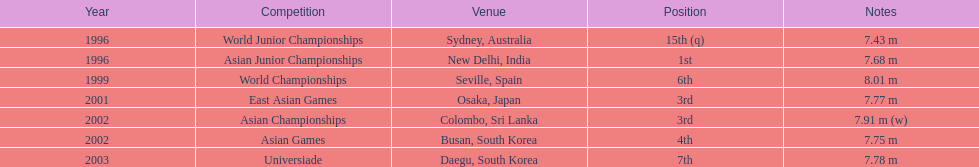Would you mind parsing the complete table? {'header': ['Year', 'Competition', 'Venue', 'Position', 'Notes'], 'rows': [['1996', 'World Junior Championships', 'Sydney, Australia', '15th (q)', '7.43 m'], ['1996', 'Asian Junior Championships', 'New Delhi, India', '1st', '7.68 m'], ['1999', 'World Championships', 'Seville, Spain', '6th', '8.01 m'], ['2001', 'East Asian Games', 'Osaka, Japan', '3rd', '7.77 m'], ['2002', 'Asian Championships', 'Colombo, Sri Lanka', '3rd', '7.91 m (w)'], ['2002', 'Asian Games', 'Busan, South Korea', '4th', '7.75 m'], ['2003', 'Universiade', 'Daegu, South Korea', '7th', '7.78 m']]} How long was huang le's longest jump in 2002? 7.91 m (w). 